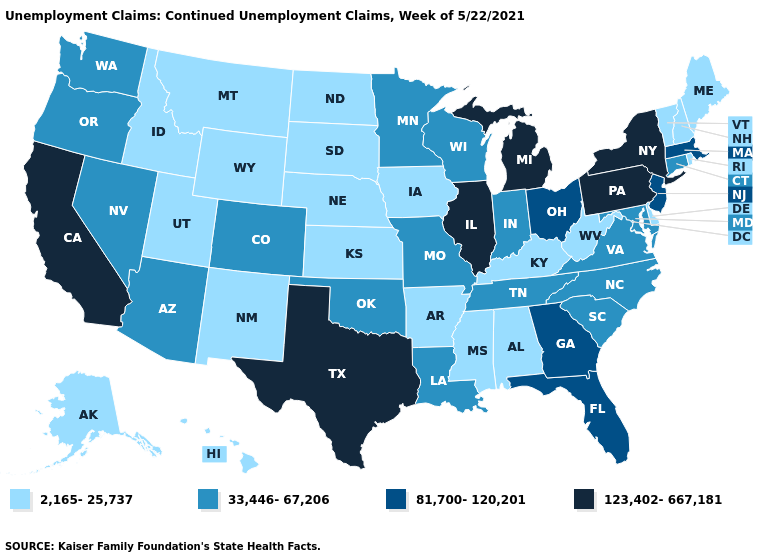Name the states that have a value in the range 33,446-67,206?
Answer briefly. Arizona, Colorado, Connecticut, Indiana, Louisiana, Maryland, Minnesota, Missouri, Nevada, North Carolina, Oklahoma, Oregon, South Carolina, Tennessee, Virginia, Washington, Wisconsin. Name the states that have a value in the range 123,402-667,181?
Give a very brief answer. California, Illinois, Michigan, New York, Pennsylvania, Texas. Does Florida have the highest value in the USA?
Answer briefly. No. Among the states that border Georgia , does Florida have the highest value?
Quick response, please. Yes. What is the highest value in the USA?
Write a very short answer. 123,402-667,181. What is the lowest value in the USA?
Short answer required. 2,165-25,737. Among the states that border New Jersey , which have the highest value?
Write a very short answer. New York, Pennsylvania. What is the value of Iowa?
Be succinct. 2,165-25,737. How many symbols are there in the legend?
Answer briefly. 4. What is the lowest value in states that border Wisconsin?
Keep it brief. 2,165-25,737. Among the states that border Tennessee , does North Carolina have the lowest value?
Concise answer only. No. What is the highest value in the South ?
Quick response, please. 123,402-667,181. Among the states that border Tennessee , which have the lowest value?
Concise answer only. Alabama, Arkansas, Kentucky, Mississippi. Name the states that have a value in the range 123,402-667,181?
Give a very brief answer. California, Illinois, Michigan, New York, Pennsylvania, Texas. Name the states that have a value in the range 123,402-667,181?
Short answer required. California, Illinois, Michigan, New York, Pennsylvania, Texas. 